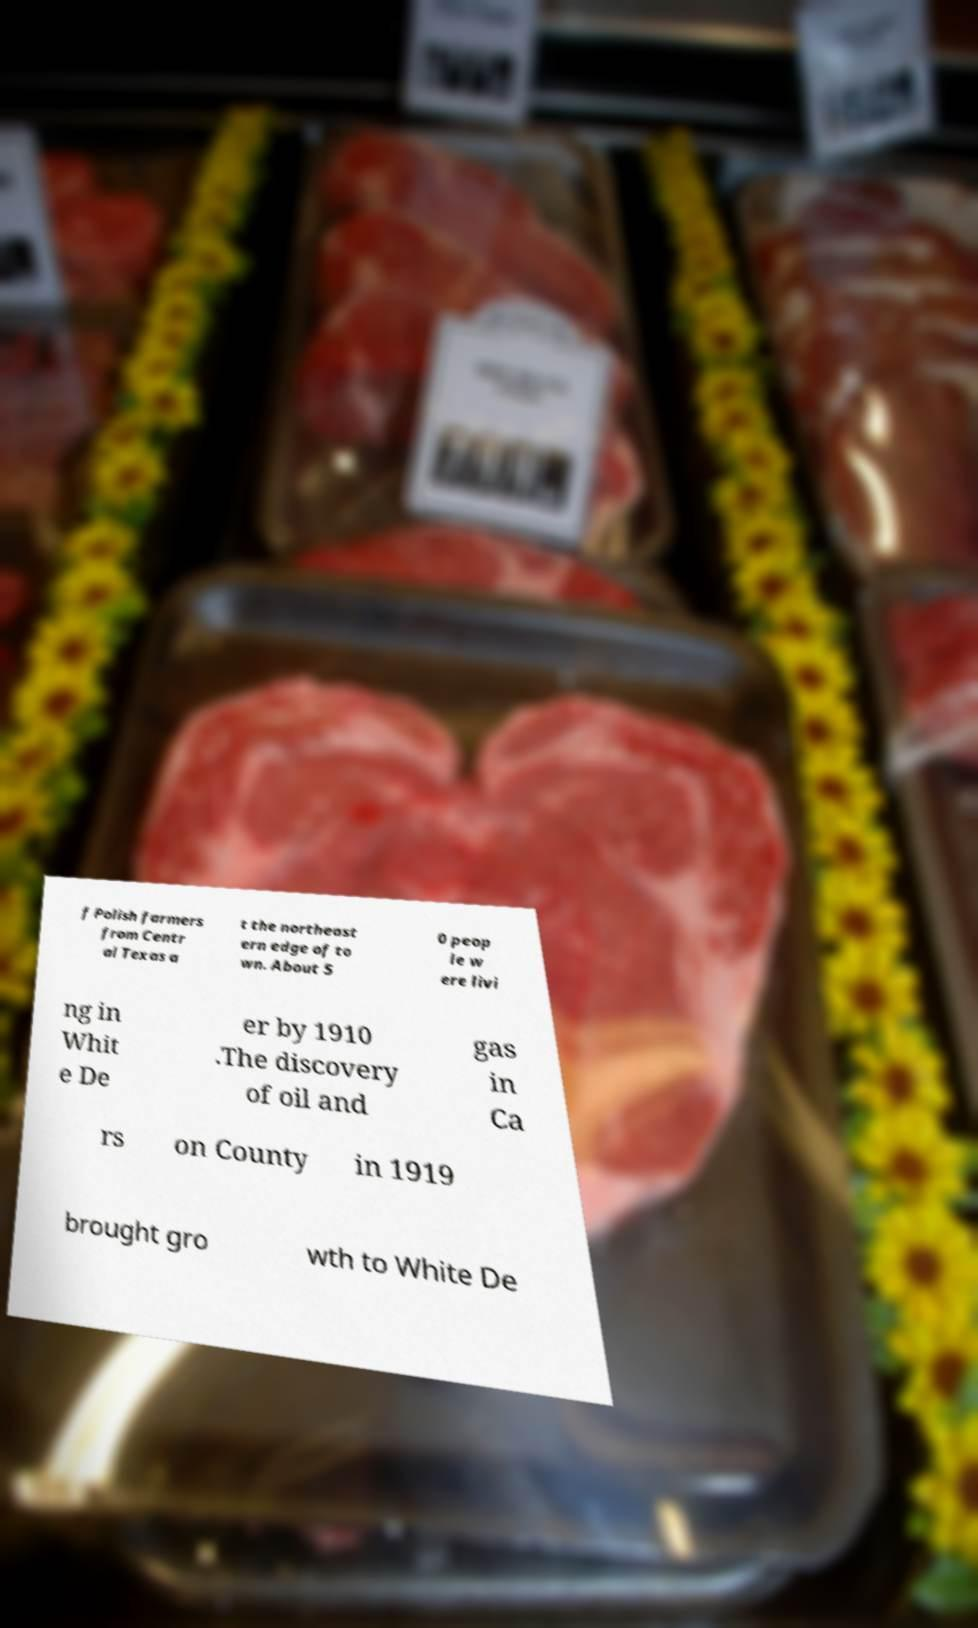Please read and relay the text visible in this image. What does it say? f Polish farmers from Centr al Texas a t the northeast ern edge of to wn. About 5 0 peop le w ere livi ng in Whit e De er by 1910 .The discovery of oil and gas in Ca rs on County in 1919 brought gro wth to White De 